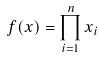Convert formula to latex. <formula><loc_0><loc_0><loc_500><loc_500>f ( x ) = \prod _ { i = 1 } ^ { n } x _ { i }</formula> 